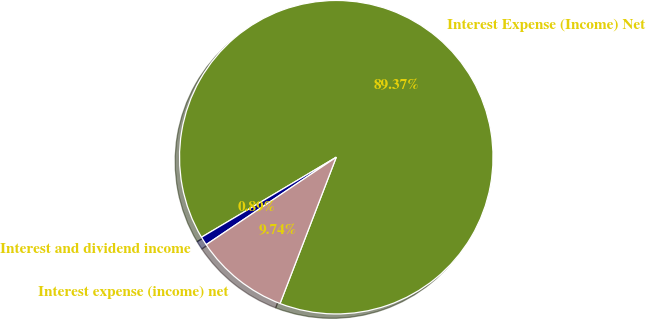<chart> <loc_0><loc_0><loc_500><loc_500><pie_chart><fcel>Interest Expense (Income) Net<fcel>Interest and dividend income<fcel>Interest expense (income) net<nl><fcel>89.37%<fcel>0.89%<fcel>9.74%<nl></chart> 